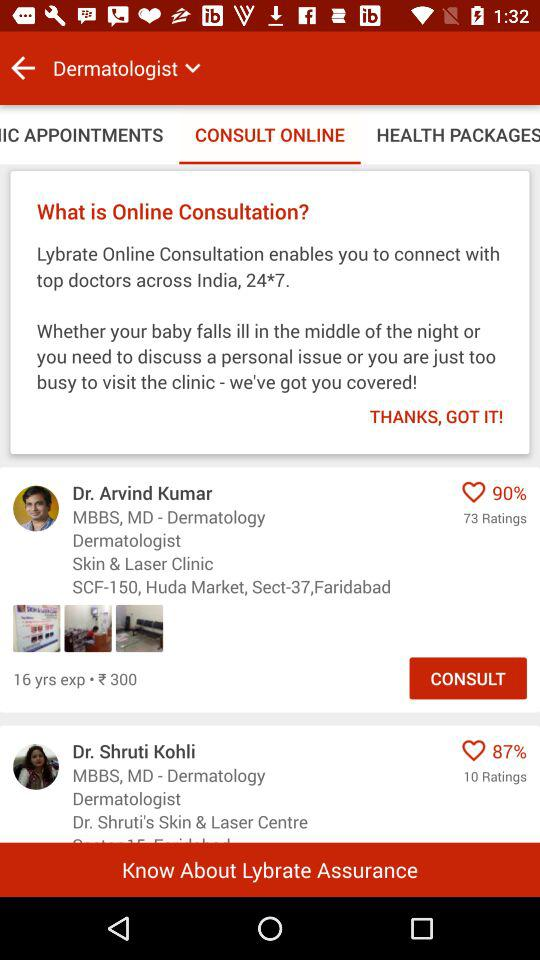How many doctors are recommended on this page?
Answer the question using a single word or phrase. 2 